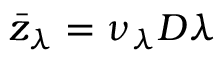<formula> <loc_0><loc_0><loc_500><loc_500>\bar { z } _ { \lambda } = \nu _ { \lambda } D \lambda</formula> 